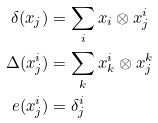<formula> <loc_0><loc_0><loc_500><loc_500>\delta ( x _ { j } ) & = \sum _ { i } x _ { i } \otimes x ^ { i } _ { j } \\ \Delta ( x ^ { i } _ { j } ) & = \sum _ { k } x ^ { i } _ { k } \otimes x ^ { k } _ { j } \\ \ e ( x ^ { i } _ { j } ) & = \delta ^ { i } _ { j }</formula> 